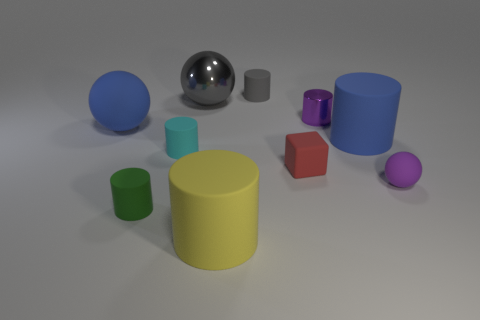Is the number of small cylinders to the left of the cyan cylinder greater than the number of red matte cubes? No, the number of small cylinders to the left of the cyan cylinder is not greater than the number of red matte cubes. Upon visual inspection, we can count the items in question to determine the accurate counts. 